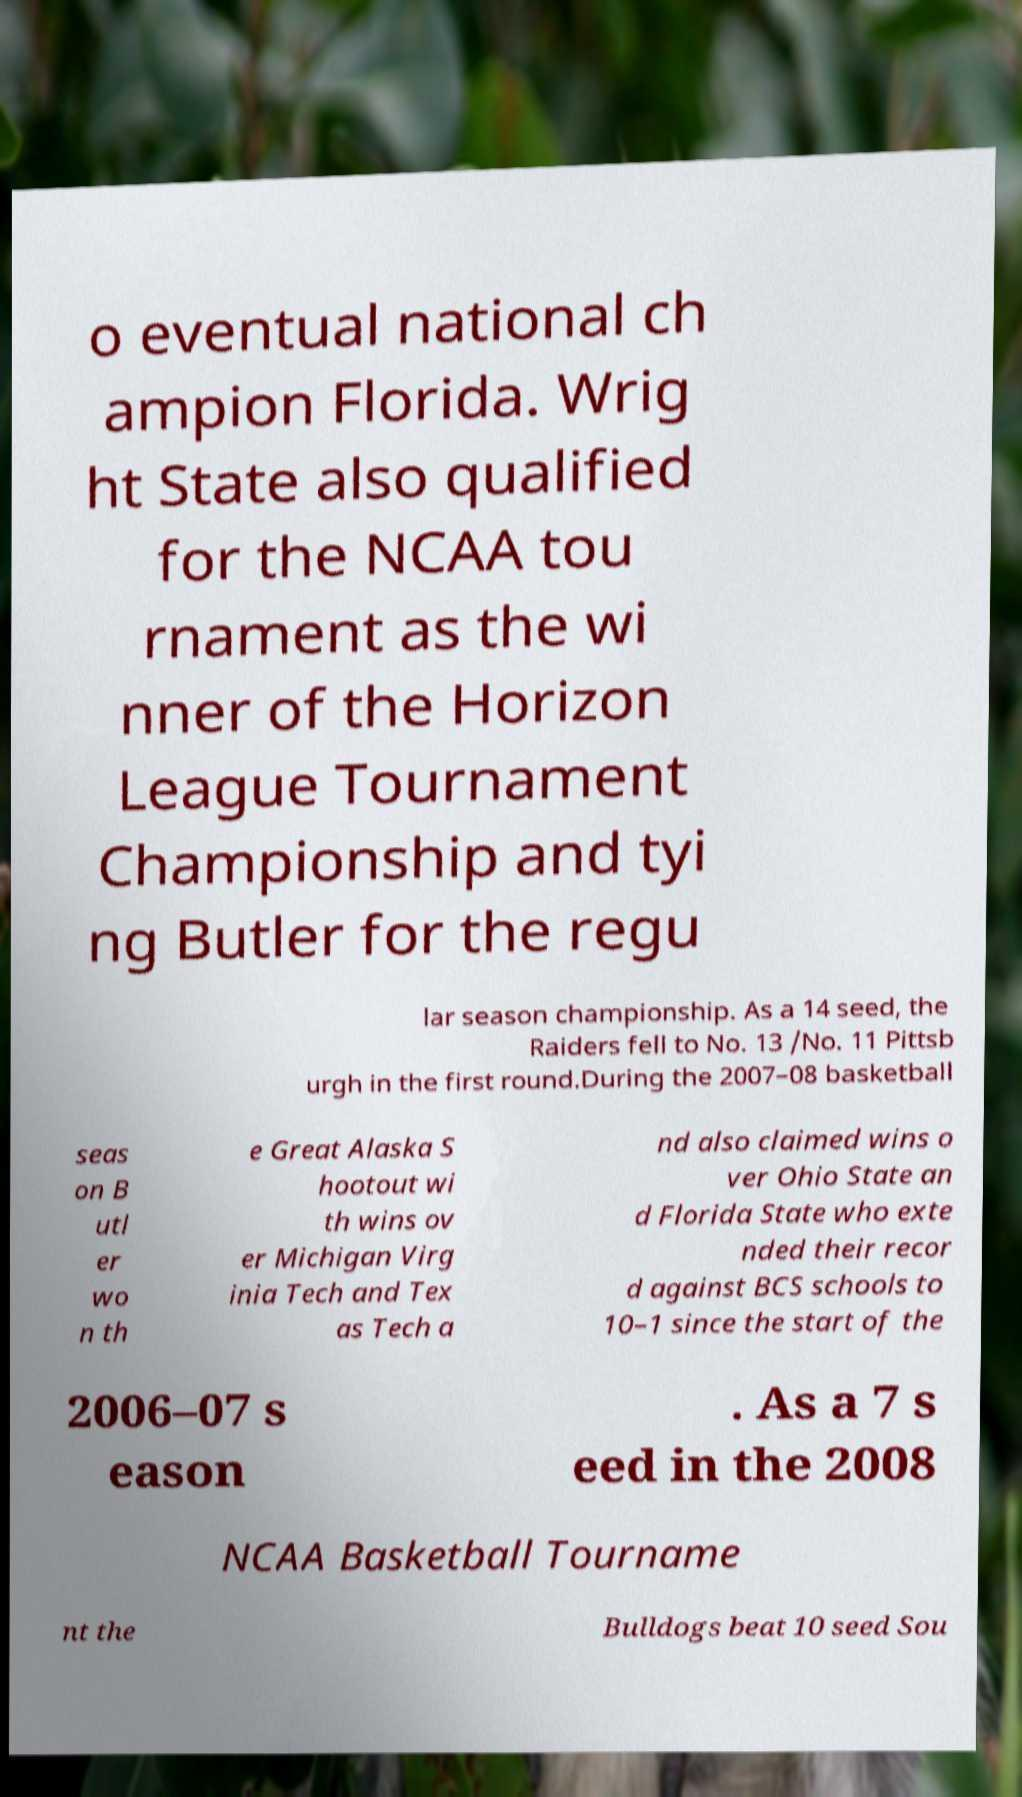There's text embedded in this image that I need extracted. Can you transcribe it verbatim? o eventual national ch ampion Florida. Wrig ht State also qualified for the NCAA tou rnament as the wi nner of the Horizon League Tournament Championship and tyi ng Butler for the regu lar season championship. As a 14 seed, the Raiders fell to No. 13 /No. 11 Pittsb urgh in the first round.During the 2007–08 basketball seas on B utl er wo n th e Great Alaska S hootout wi th wins ov er Michigan Virg inia Tech and Tex as Tech a nd also claimed wins o ver Ohio State an d Florida State who exte nded their recor d against BCS schools to 10–1 since the start of the 2006–07 s eason . As a 7 s eed in the 2008 NCAA Basketball Tourname nt the Bulldogs beat 10 seed Sou 